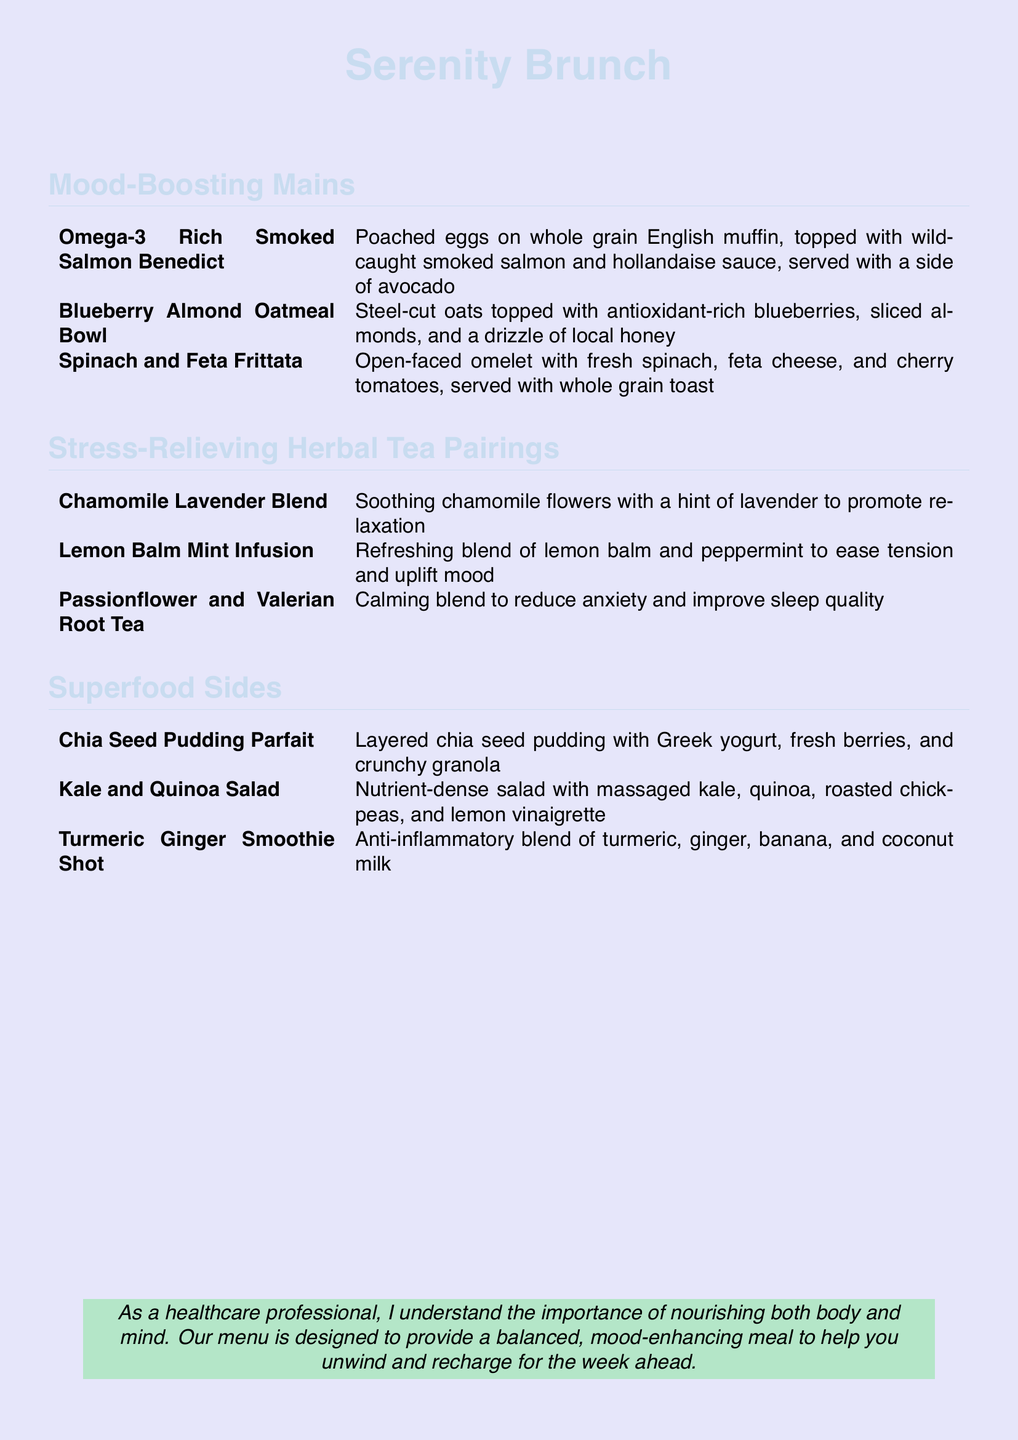What is the name of the brunch menu? The title of the brunch menu is prominently displayed at the top of the document.
Answer: Serenity Brunch How many mood-boosting mains are listed? The number of items in the "Mood-Boosting Mains" section is counted.
Answer: 3 What type of fish is used in the Smoked Salmon Benedict? The type of fish used in this dish is specified in the description.
Answer: Wild-caught smoked salmon Which tea is a calming blend for reducing anxiety? The description of the tea that helps reduce anxiety is mentioned.
Answer: Passionflower and Valerian Root Tea What is included in the Kale and Quinoa Salad? The ingredients in this salad are detailed in the document.
Answer: Massaged kale, quinoa, roasted chickpeas, lemon vinaigrette What type of pudding is featured in the Superfood Sides? The specific type of pudding is referenced in the "Superfood Sides" section.
Answer: Chia Seed Pudding Parfait Which herbal tea is recommended for relaxation? The tea known to promote relaxation is indicated in the section on herbal teas.
Answer: Chamomile Lavender Blend What is the main purpose of the menu as stated in the document? The intention behind the menu design is summarized at the bottom of the document.
Answer: Nourishing both body and mind 